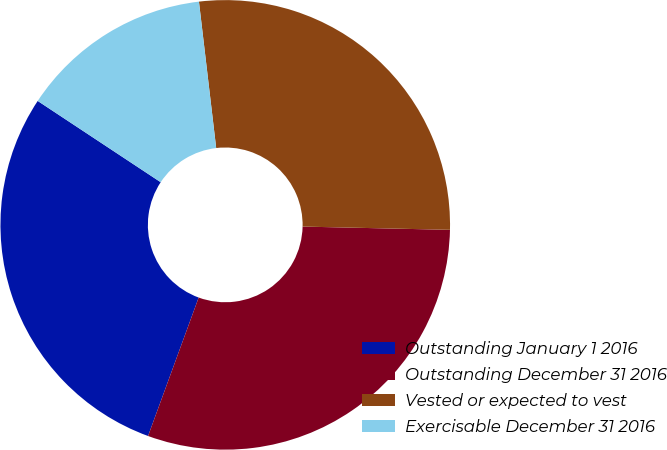Convert chart. <chart><loc_0><loc_0><loc_500><loc_500><pie_chart><fcel>Outstanding January 1 2016<fcel>Outstanding December 31 2016<fcel>Vested or expected to vest<fcel>Exercisable December 31 2016<nl><fcel>28.72%<fcel>30.23%<fcel>27.22%<fcel>13.84%<nl></chart> 